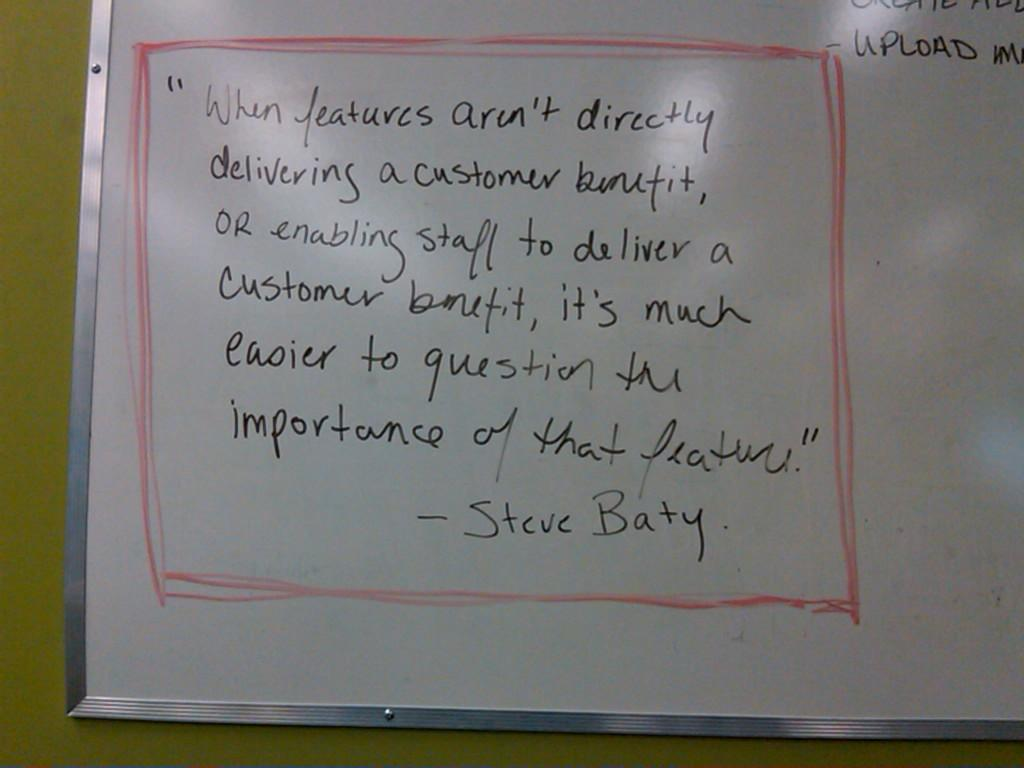<image>
Provide a brief description of the given image. White board which shows a saying by "Steve Baty". 